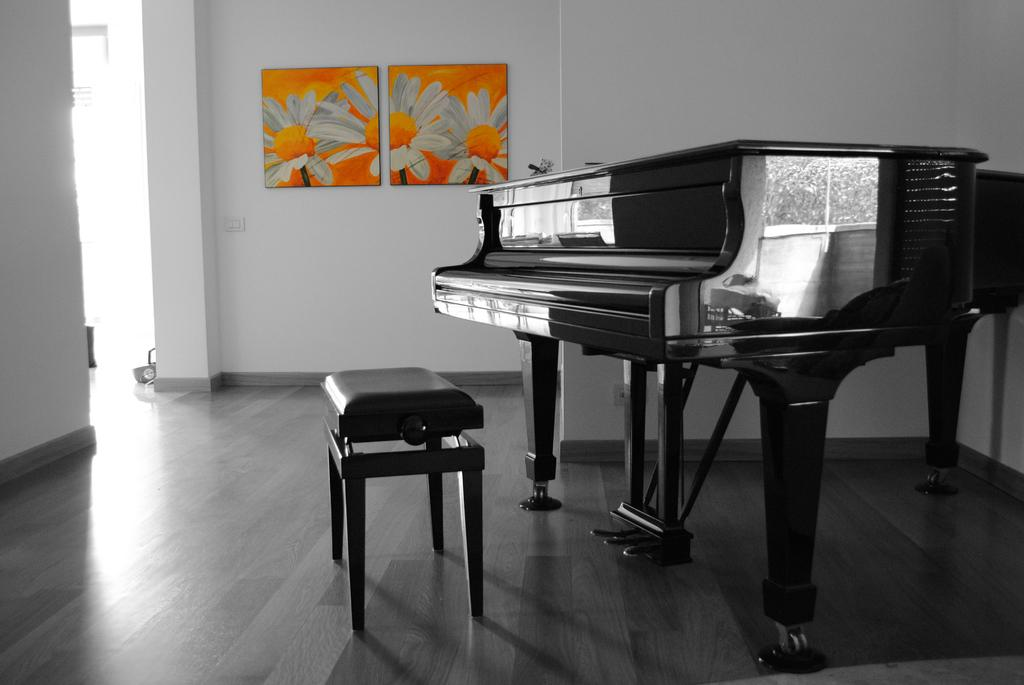What musical instrument is present in the image? There is a piano in the image. What type of furniture is in the image? There is a chair in the image. What decorative items are attached to the wall in the image? There are two frames attached to the wall in the image. How many friends are playing on the farm in the image? There is no farm or friends present in the image. What type of group activity is taking place in the image? There is no group activity present in the image; it features a piano, a chair, and two frames on the wall. 